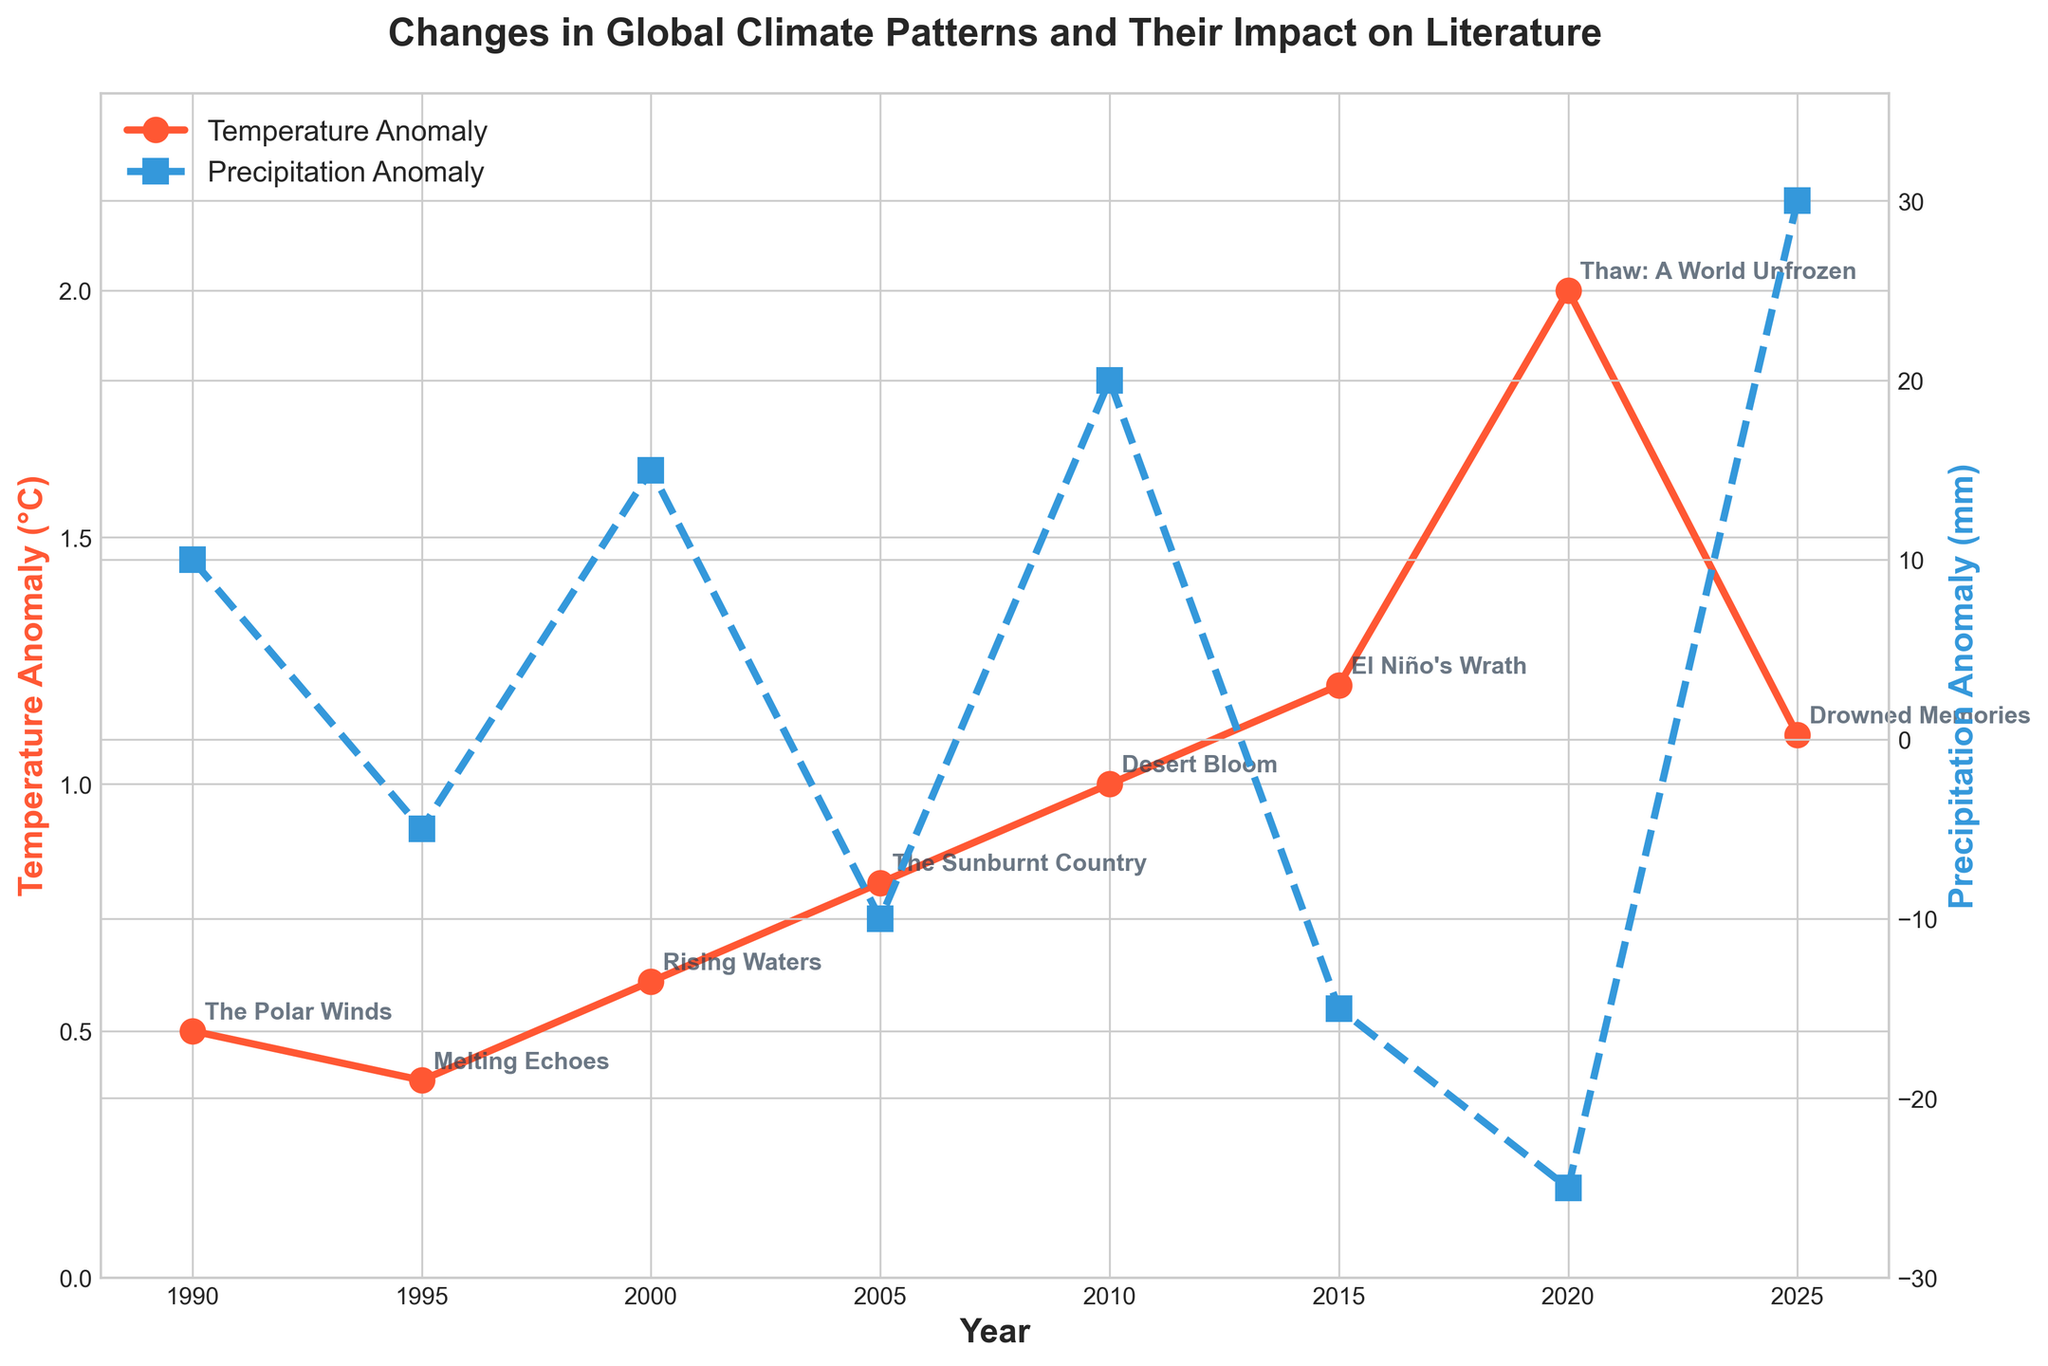What is the title of the plot? The title of the plot is usually found at the top center of the figure. From the provided information, the title is "Changes in Global Climate Patterns and Their Impact on Literature."
Answer: Changes in Global Climate Patterns and Their Impact on Literature How many different years does the plot cover? Count the unique years on the x-axis of the plot. According to the provided data, the years are 1990, 1995, 2000, 2005, 2010, 2015, 2020, and 2025.
Answer: 8 Which year shows the highest temperature anomaly? Identify the peak point on the temperature anomaly line on the plot. The data shows that 2020 has the highest temperature anomaly of 2.0°C.
Answer: 2020 What is the precipitation anomaly for the year 2000? Locate the data point for the year 2000 on the precipitation anomaly line and check its value.
Answer: 15 mm Which region experienced the highest temperature anomaly and what was the literary work associated with it? From the plot and provided data, the highest temperature anomaly of 2.0°C occurred in the Arctic in 2020, associated with the work "Thaw: A World Unfrozen."
Answer: Arctic, "Thaw: A World Unfrozen" Between which years does the temperature anomaly show the most significant change? Analyze the slope of the temperature anomaly line to find where the change is steepest. The most notable change appears between 2015 and 2020.
Answer: 2015 and 2020 Which year had the largest negative precipitation anomaly and what was the region and literary work related to it? Find the lowest point on the precipitation anomaly line. The largest negative anomaly is -25 mm in 2020, related to the Arctic and the literary work "Thaw: A World Unfrozen."
Answer: 2020, Arctic, "Thaw: A World Unfrozen" How does the temperature anomaly in 2010 compare to that in 2000? Compare the temperature anomaly values for the years 2010 and 2000. In 2000, the anomaly was 0.6°C, and in 2010, it was 1.0°C. 2010 is higher by 0.4°C.
Answer: 2010 is 0.4°C higher What is the average temperature anomaly across the years provided? Add up all the temperature anomaly values and divide by the number of years. (0.5 + 0.4 + 0.6 + 0.8 + 1.0 + 1.2 + 2.0 + 1.1) / 8 = 7.6 / 8 = 0.95°C
Answer: 0.95°C What trend is observed in precipitation anomalies from 2010 to 2025? Observe the slope of the precipitation anomaly line between 2010 and 2025. The anomalies show a sharp increase, indicating increasing precipitation deviations.
Answer: Increasing trend 